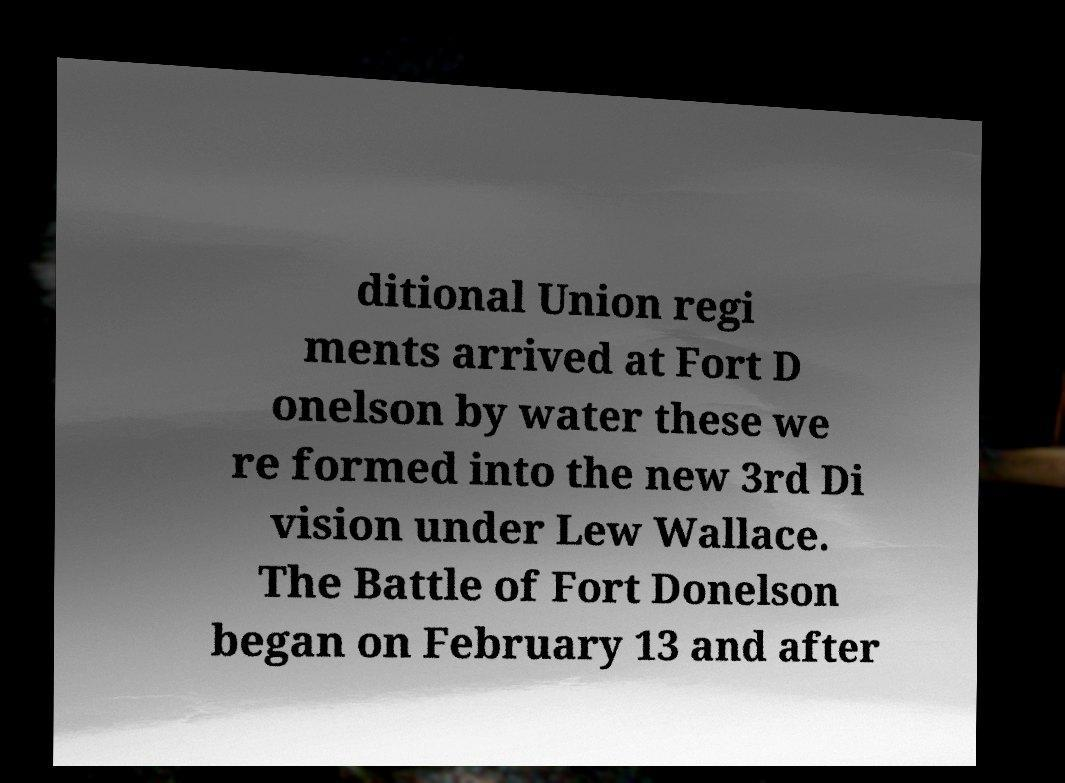Could you assist in decoding the text presented in this image and type it out clearly? ditional Union regi ments arrived at Fort D onelson by water these we re formed into the new 3rd Di vision under Lew Wallace. The Battle of Fort Donelson began on February 13 and after 